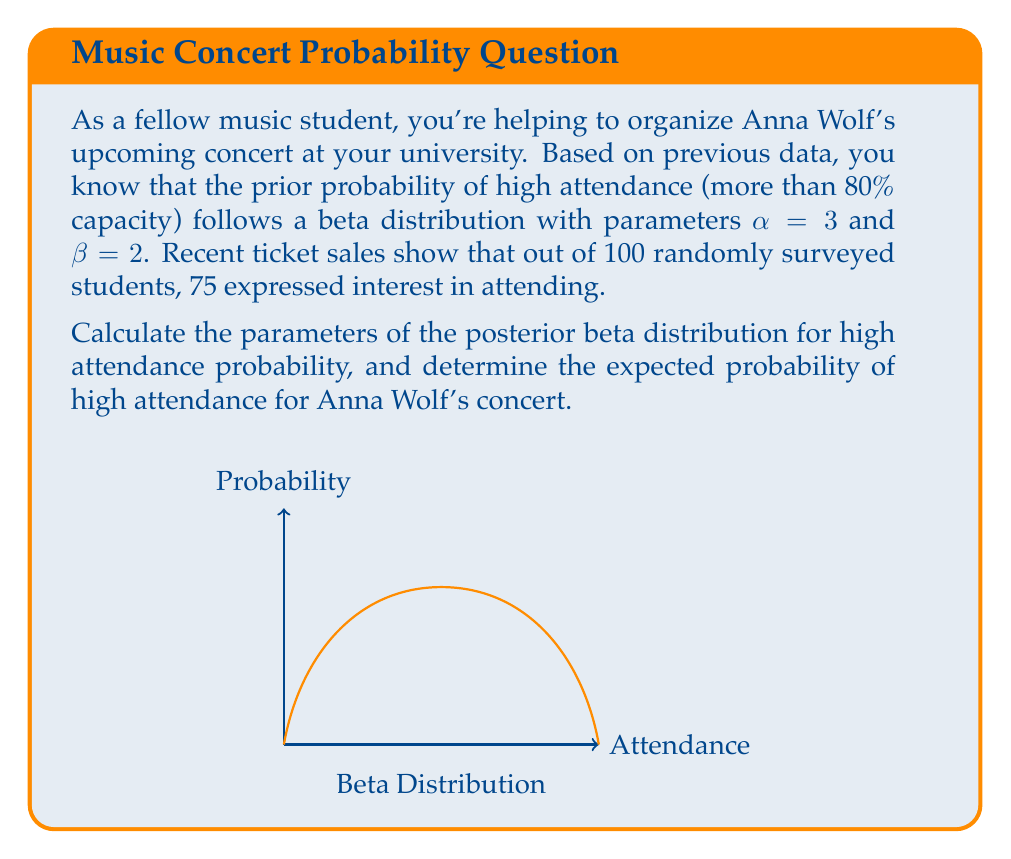Solve this math problem. Let's approach this step-by-step using Bayesian inference:

1) The prior distribution is Beta($\alpha$, $\beta$) with $\alpha=3$ and $\beta=2$.

2) We use the beta-binomial conjugate prior. For a beta prior and binomial likelihood, the posterior is also a beta distribution.

3) The posterior parameters are calculated as:
   $\alpha_{posterior} = \alpha_{prior} + \text{successes}$
   $\beta_{posterior} = \beta_{prior} + \text{failures}$

4) In our case:
   $\alpha_{posterior} = 3 + 75 = 78$
   $\beta_{posterior} = 2 + (100 - 75) = 27$

5) So, the posterior distribution is Beta(78, 27).

6) The expected value (mean) of a Beta($\alpha$, $\beta$) distribution is given by:
   $$E[X] = \frac{\alpha}{\alpha + \beta}$$

7) Plugging in our posterior parameters:
   $$E[X] = \frac{78}{78 + 27} = \frac{78}{105} \approx 0.7429$$

Therefore, the expected probability of high attendance is approximately 0.7429 or 74.29%.
Answer: Beta(78, 27); 0.7429 